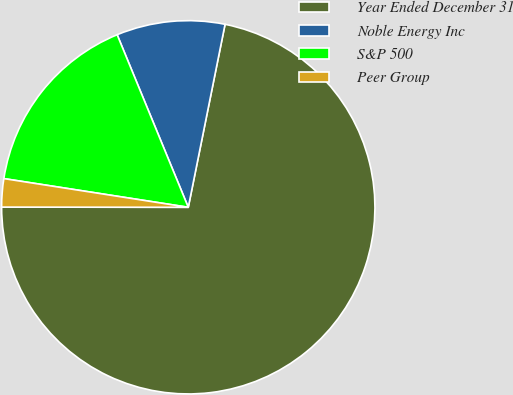Convert chart. <chart><loc_0><loc_0><loc_500><loc_500><pie_chart><fcel>Year Ended December 31<fcel>Noble Energy Inc<fcel>S&P 500<fcel>Peer Group<nl><fcel>71.86%<fcel>9.38%<fcel>16.32%<fcel>2.44%<nl></chart> 